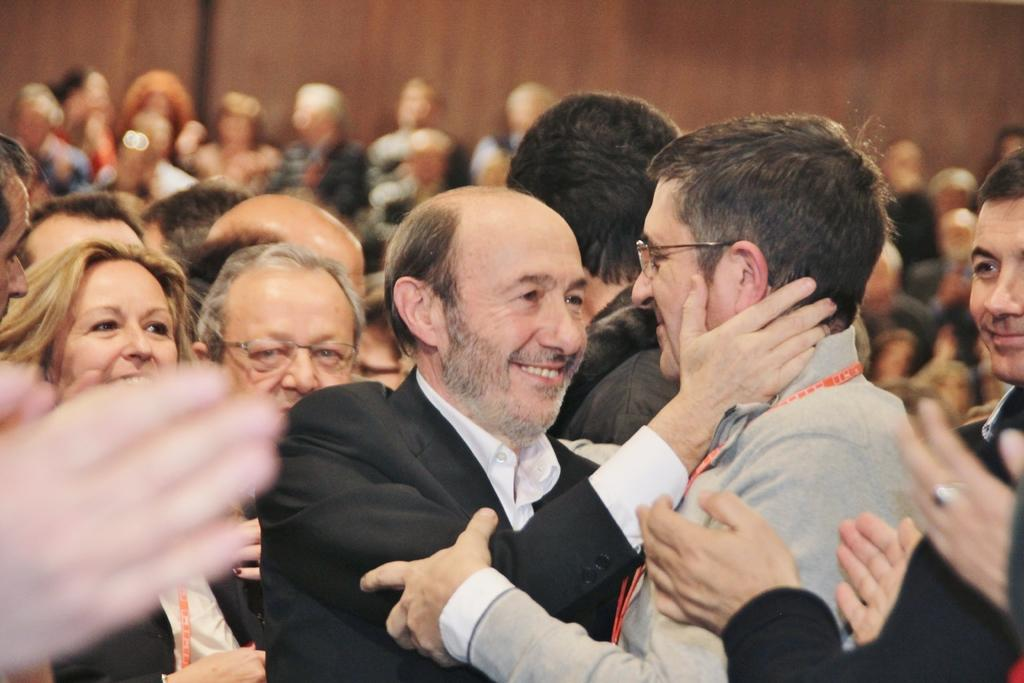Where is the location of the image? The image is inside an auditorium. What can be observed in the auditorium? There are people in the auditorium. What type of pest can be seen crawling on the seashore in the image? There is no seashore or pest present in the image; it is inside an auditorium with people. 